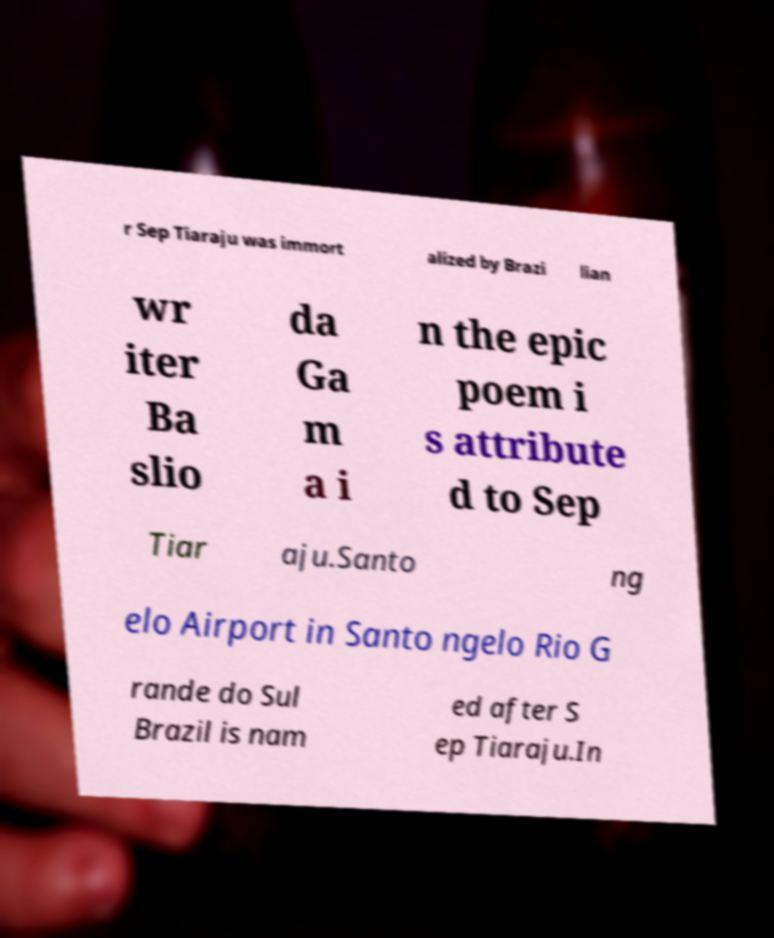Could you assist in decoding the text presented in this image and type it out clearly? r Sep Tiaraju was immort alized by Brazi lian wr iter Ba slio da Ga m a i n the epic poem i s attribute d to Sep Tiar aju.Santo ng elo Airport in Santo ngelo Rio G rande do Sul Brazil is nam ed after S ep Tiaraju.In 